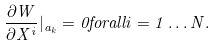Convert formula to latex. <formula><loc_0><loc_0><loc_500><loc_500>\frac { \partial W } { \partial X ^ { i } } | _ { a _ { k } } = 0 f o r a l l i = 1 \dots N .</formula> 